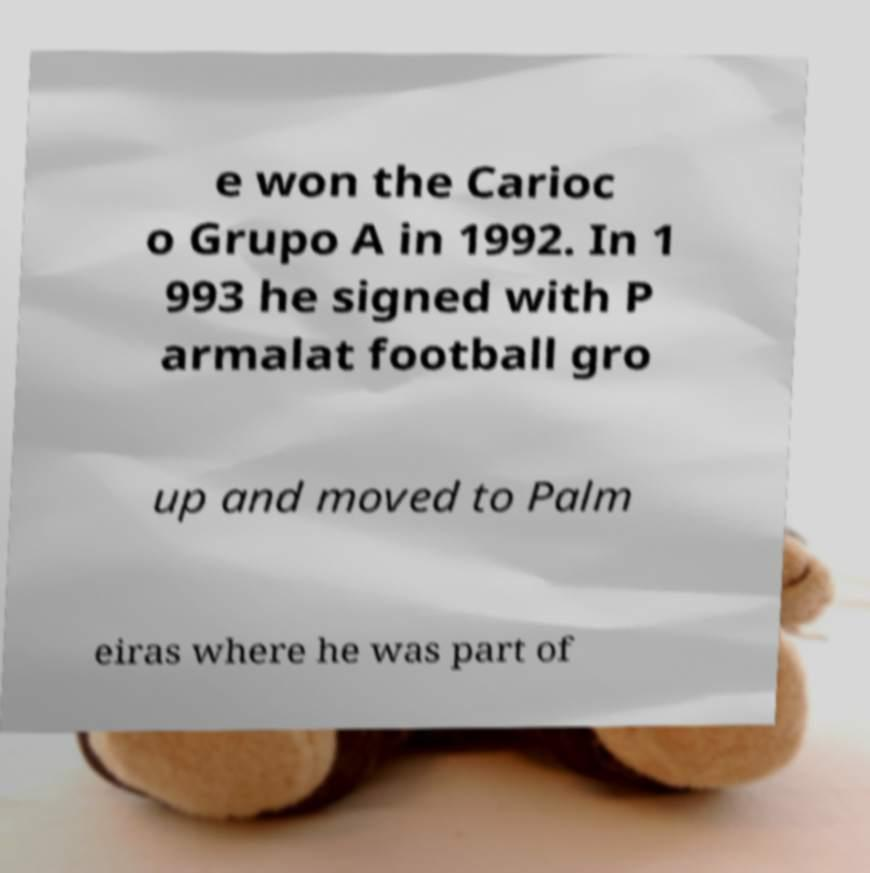Please read and relay the text visible in this image. What does it say? e won the Carioc o Grupo A in 1992. In 1 993 he signed with P armalat football gro up and moved to Palm eiras where he was part of 